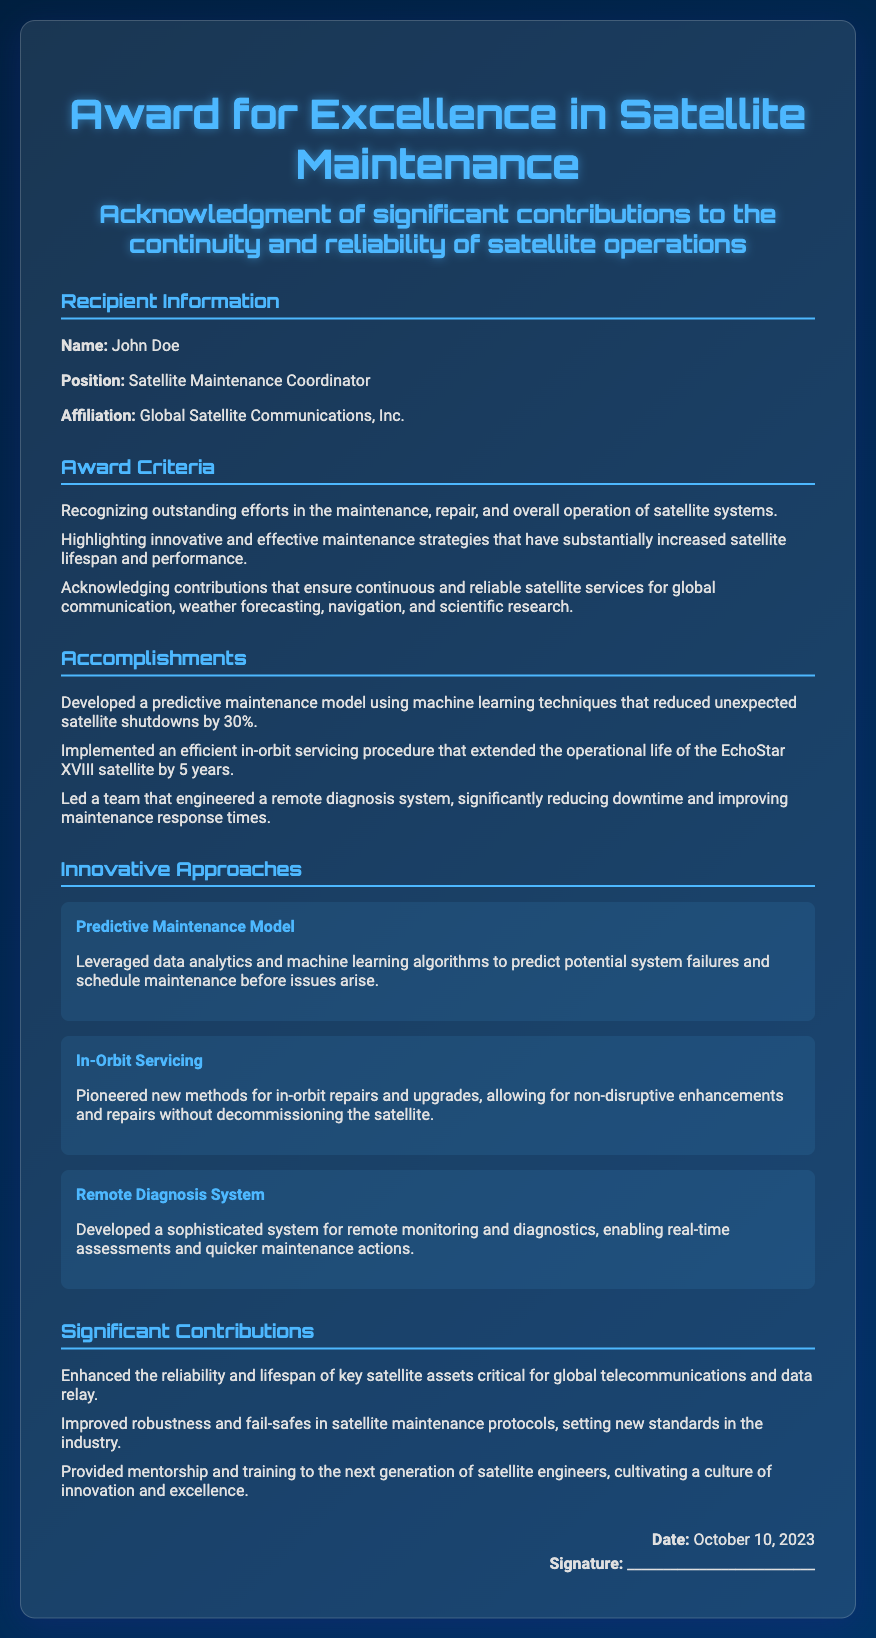What is the name of the recipient? The recipient's name is mentioned in the document, which is John Doe.
Answer: John Doe What is the position of the recipient? The document states the recipient's position as Satellite Maintenance Coordinator.
Answer: Satellite Maintenance Coordinator What was the date of the award? The date is provided in the document, stated clearly as October 10, 2023.
Answer: October 10, 2023 How much did the predictive maintenance model reduce unexpected satellite shutdowns? The document specifies that the predictive maintenance model reduced unexpected shutdowns by 30%.
Answer: 30% What were the innovative approaches mentioned in the document? The document lists three innovative approaches: Predictive Maintenance Model, In-Orbit Servicing, and Remote Diagnosis System.
Answer: Predictive Maintenance Model, In-Orbit Servicing, Remote Diagnosis System Which organization is the recipient affiliated with? The document shows that the recipient is affiliated with Global Satellite Communications, Inc.
Answer: Global Satellite Communications, Inc What is one significant contribution highlighted in the document? The document mentions that enhancing reliability and lifespan of key satellite assets is a significant contribution.
Answer: Enhanced the reliability and lifespan of key satellite assets What does the award recognize? The award recognizes outstanding efforts in satellite maintenance, repair, and overall operation of satellite systems.
Answer: Outstanding efforts in the maintenance, repair, and overall operation of satellite systems Who signed the diploma? The document includes a placeholder for a signature but does not provide a specific name for the signer.
Answer: __________________________ 